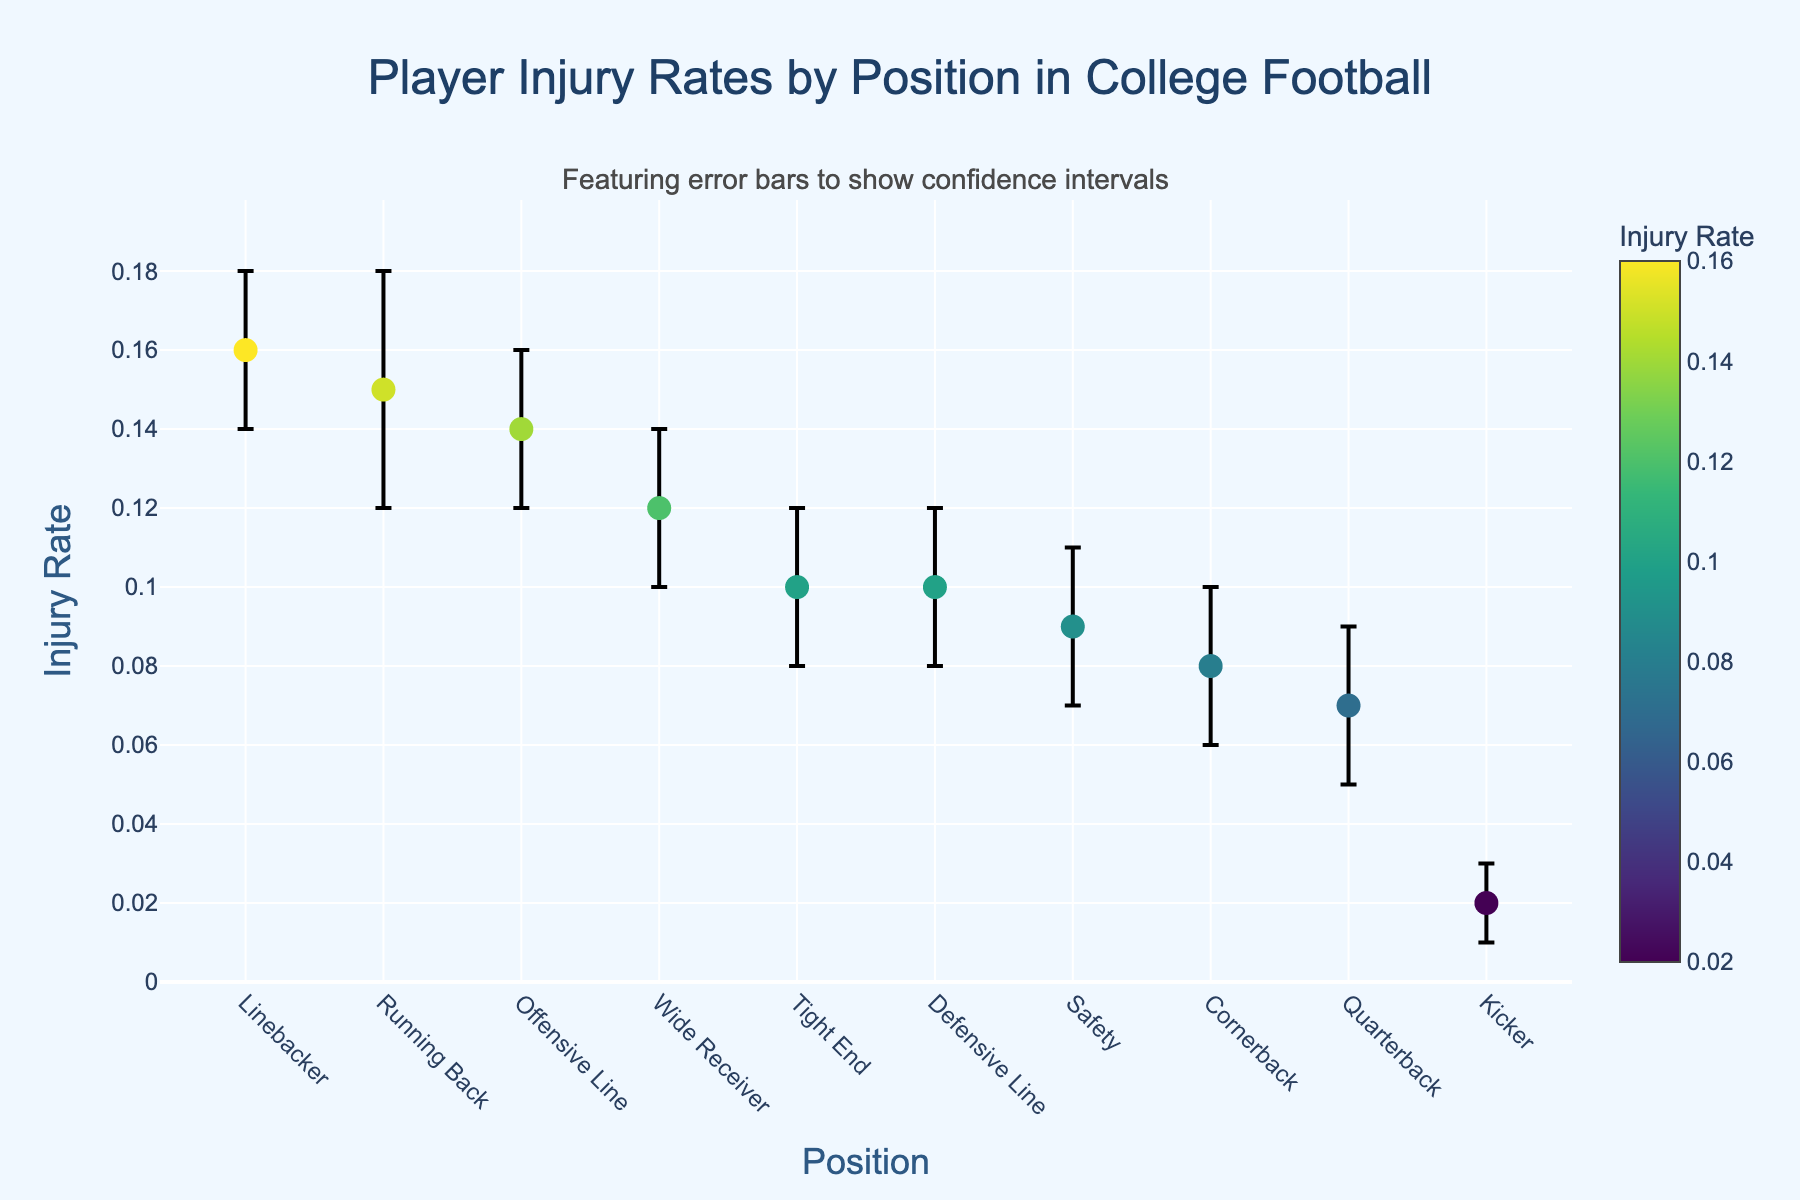Which position has the highest injury rate? By looking at the y-axis and finding the highest dot, we can see it's the Linebacker position.
Answer: Linebacker What's the range of the injury rate for Running Back? The lower confidence interval for Running Back is 0.12, and the upper confidence interval is 0.18. The range is 0.18 - 0.12.
Answer: 0.06 Which position has the lowest injury rate? By looking at the y-axis and finding the lowest dot, we can see it's the Kicker position.
Answer: Kicker How does the injury rate for Quarterback compare to that for Safety? The dot for Quarterback is at 0.07, while the dot for Safety is at 0.09. Hence, the injury rate for Quarterback is lower than that for Safety.
Answer: Quarterback is lower What is the average injury rate for Offensive Line and Defensive Line? The injury rates for Offensive Line and Defensive Line are 0.14 and 0.10, respectively. The average is (0.14 + 0.10) / 2.
Answer: 0.12 Which position has the largest error bar? The error bars represent the confidence intervals. Linebacker, with a range from 0.14 to 0.18, has the largest error bar, ranging 0.04.
Answer: Linebacker Is the injury rate for Wide Receiver higher than that for Tight End? By comparing the y-axis positions, we see the dot for Wide Receiver at 0.12 is higher than the dot for Tight End at 0.10.
Answer: Yes How many positions have an injury rate higher than 0.1? By examining the positions of the dots on the y-axis, we can count 5 positions (Running Back, Offensive Line, Wide Receiver, Linebacker, Tight End) above 0.1.
Answer: 5 What is the injury rate difference between the highest and lowest positions? The highest injury rate is 0.16 (Linebacker), and the lowest is 0.02 (Kicker). The difference is 0.16 - 0.02.
Answer: 0.14 How many positions have a confidence interval that includes an injury rate of 0.10? The confidence intervals for Quarterback, Wide Receiver, Tight End, Defensive Line, Safety, and Cornerback all include 0.10.
Answer: 6 